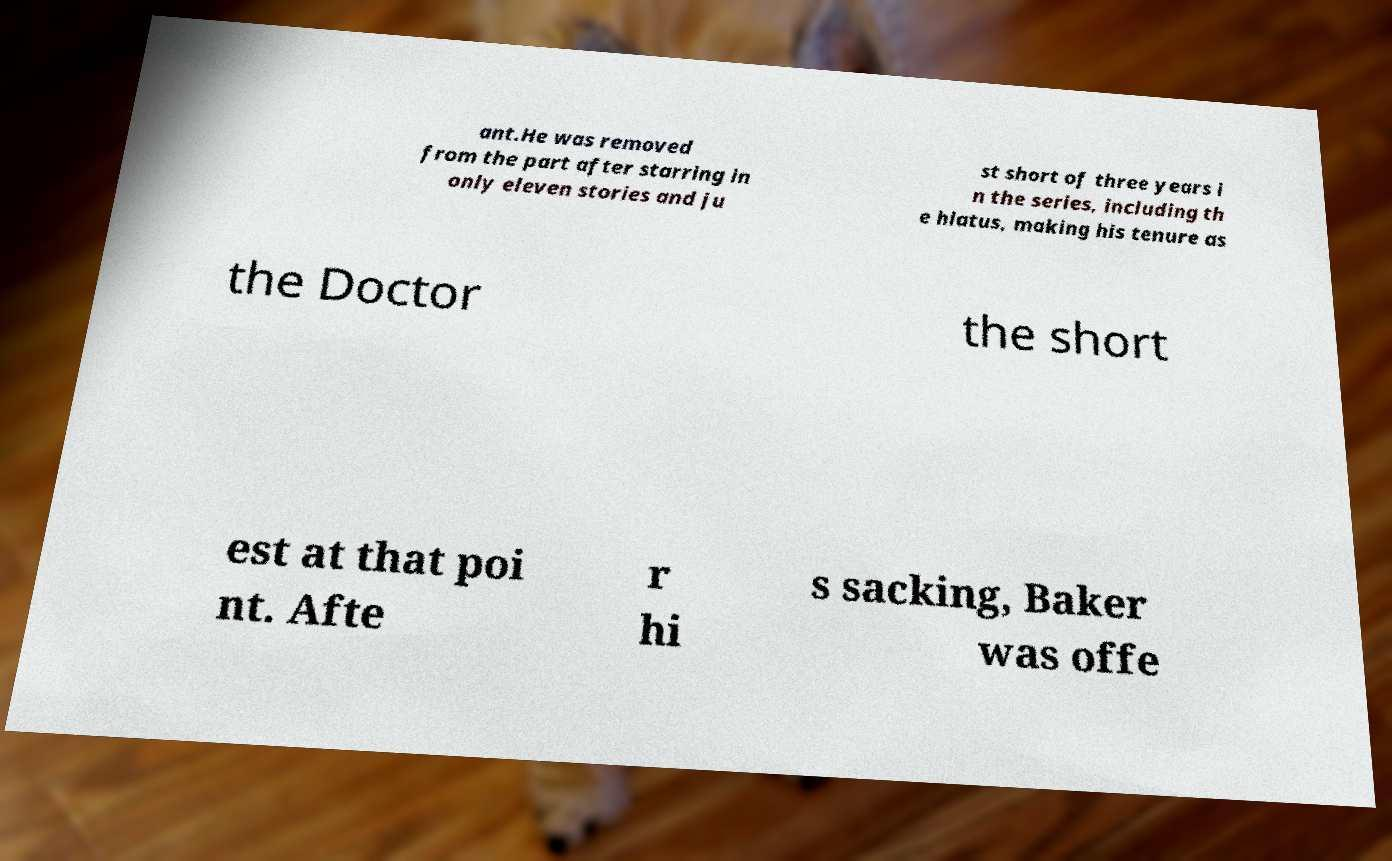Could you assist in decoding the text presented in this image and type it out clearly? ant.He was removed from the part after starring in only eleven stories and ju st short of three years i n the series, including th e hiatus, making his tenure as the Doctor the short est at that poi nt. Afte r hi s sacking, Baker was offe 